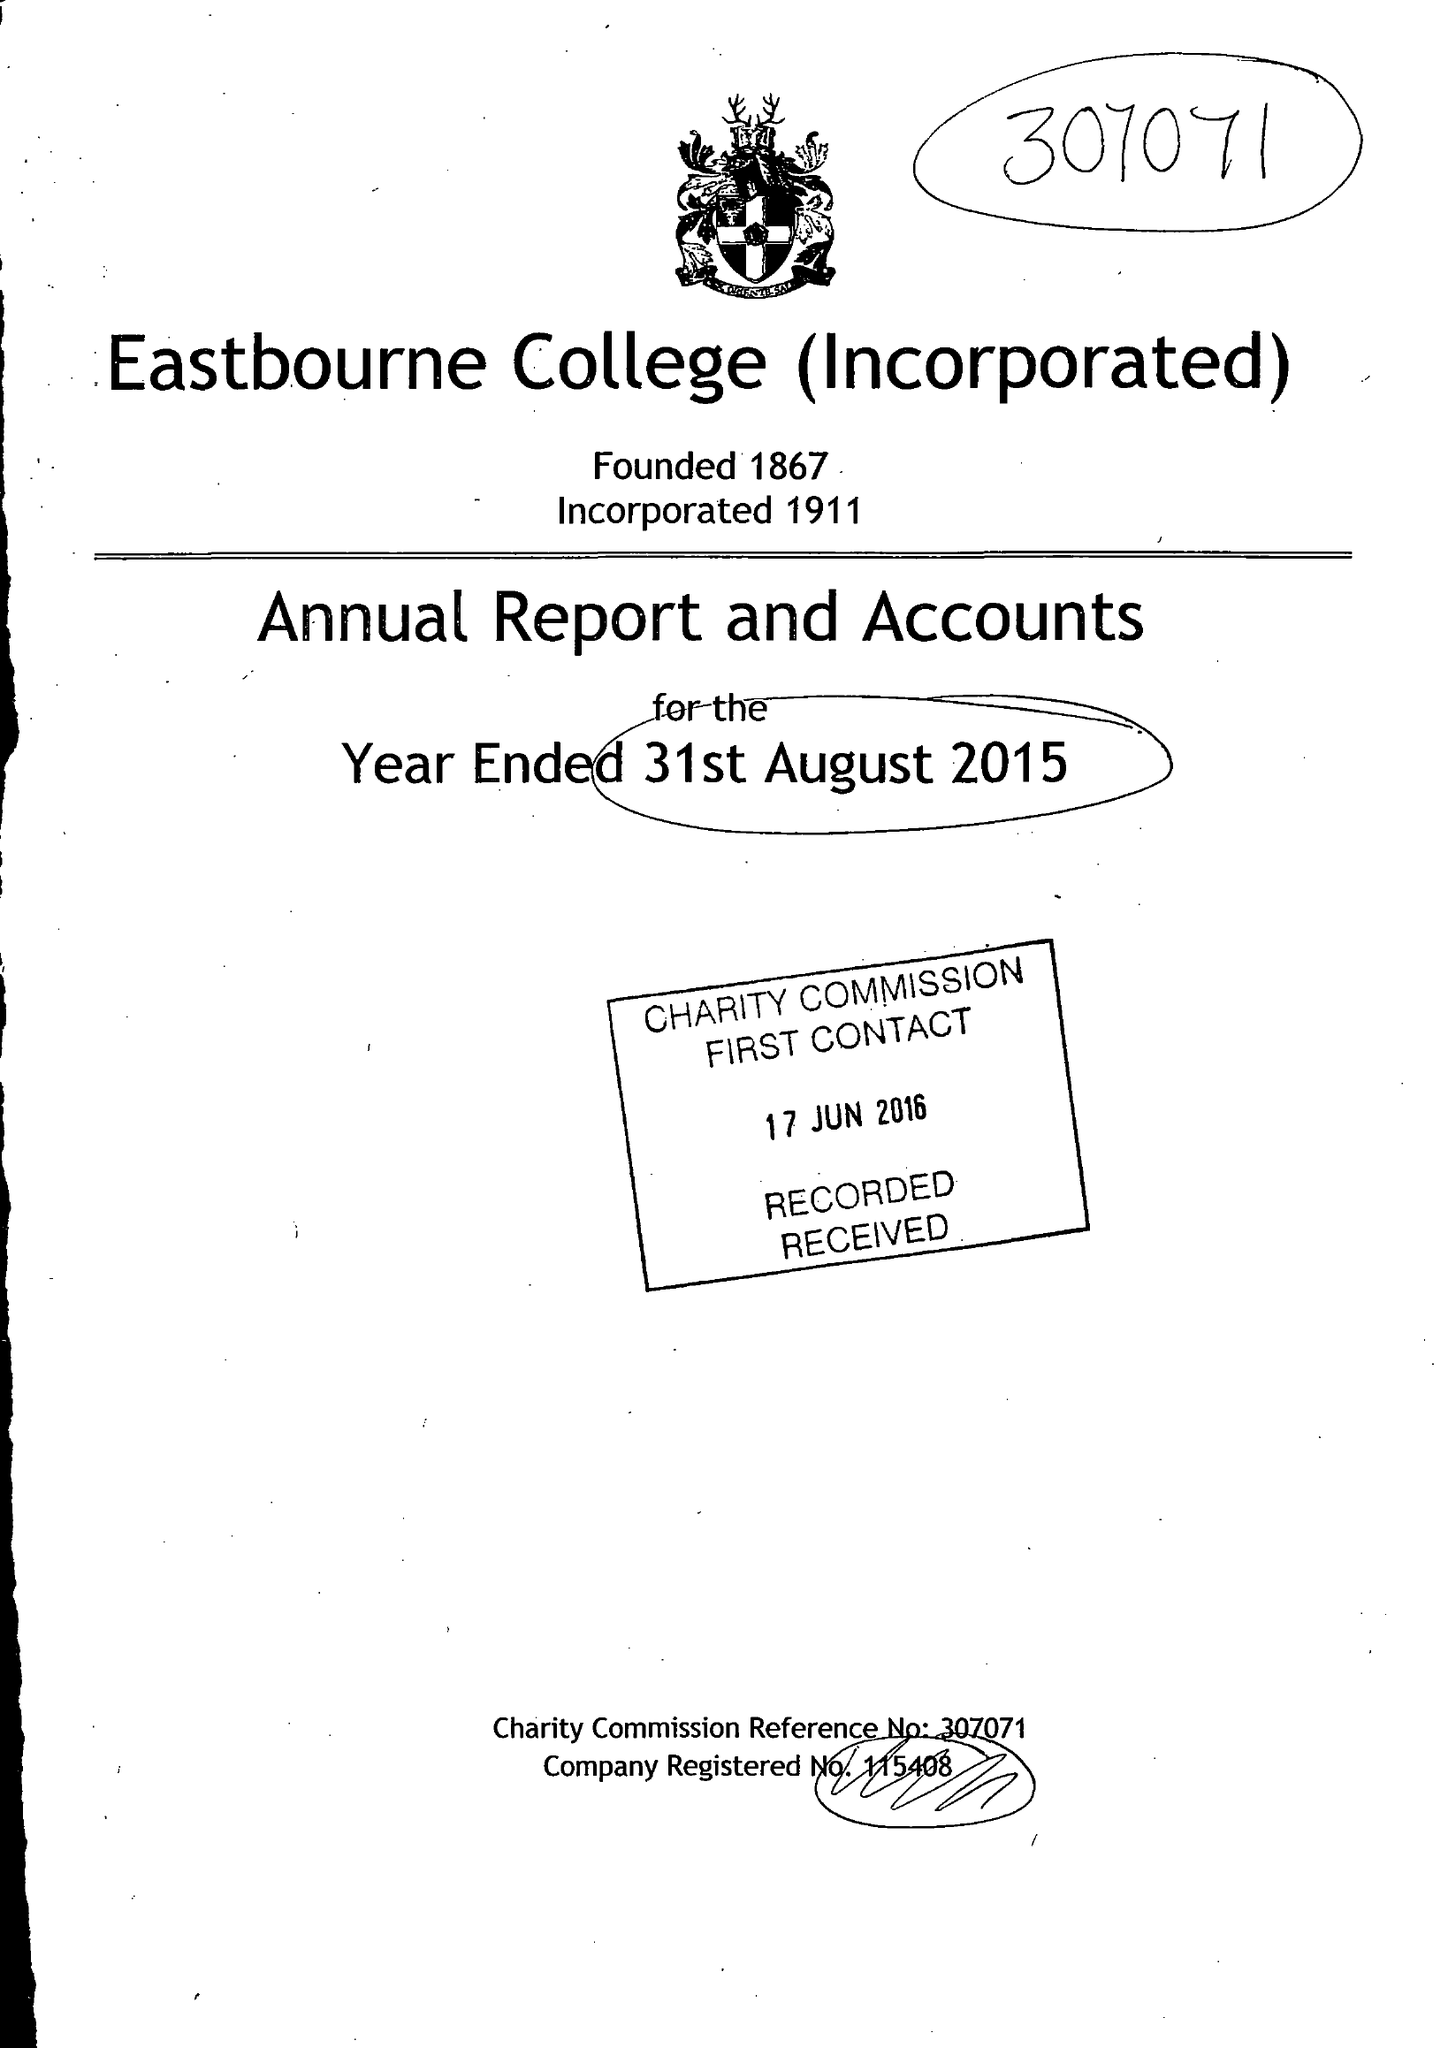What is the value for the spending_annually_in_british_pounds?
Answer the question using a single word or phrase. 19778000.00 